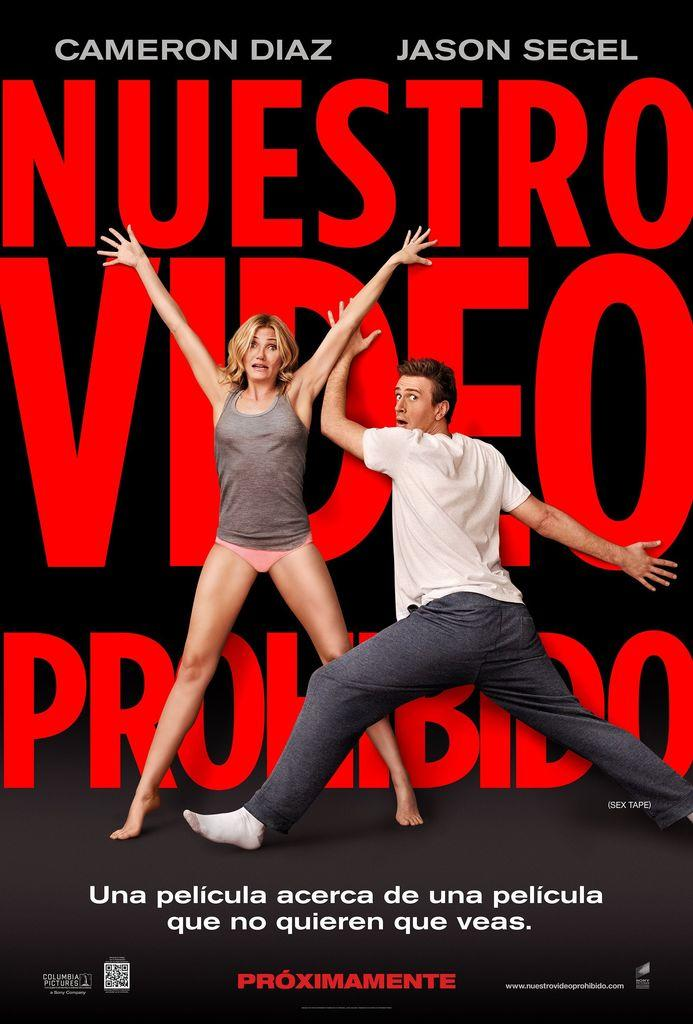Who is present in the image? There is a woman and a man in the image. What are the woman and the man wearing? The woman is wearing a t-shirt and shorts, while the man is wearing a t-shirt and trousers. What are the woman and the man doing in the image? Both the woman and the man are posing for the image. What type of humor can be seen in the image? There is no humor depicted in the image; it simply shows a woman and a man posing. 